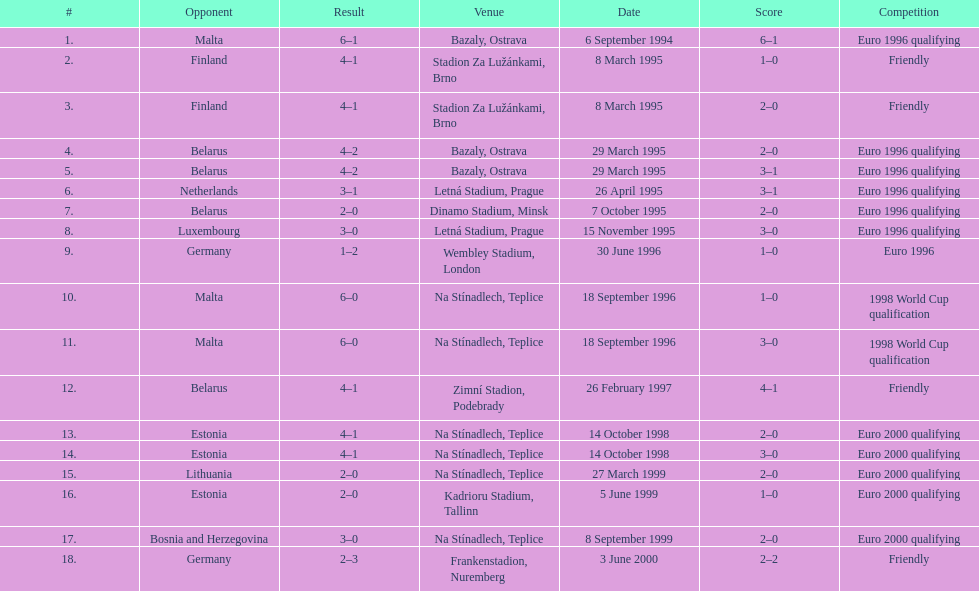List the opponent in which the result was the least out of all the results. Germany. Can you give me this table as a dict? {'header': ['#', 'Opponent', 'Result', 'Venue', 'Date', 'Score', 'Competition'], 'rows': [['1.', 'Malta', '6–1', 'Bazaly, Ostrava', '6 September 1994', '6–1', 'Euro 1996 qualifying'], ['2.', 'Finland', '4–1', 'Stadion Za Lužánkami, Brno', '8 March 1995', '1–0', 'Friendly'], ['3.', 'Finland', '4–1', 'Stadion Za Lužánkami, Brno', '8 March 1995', '2–0', 'Friendly'], ['4.', 'Belarus', '4–2', 'Bazaly, Ostrava', '29 March 1995', '2–0', 'Euro 1996 qualifying'], ['5.', 'Belarus', '4–2', 'Bazaly, Ostrava', '29 March 1995', '3–1', 'Euro 1996 qualifying'], ['6.', 'Netherlands', '3–1', 'Letná Stadium, Prague', '26 April 1995', '3–1', 'Euro 1996 qualifying'], ['7.', 'Belarus', '2–0', 'Dinamo Stadium, Minsk', '7 October 1995', '2–0', 'Euro 1996 qualifying'], ['8.', 'Luxembourg', '3–0', 'Letná Stadium, Prague', '15 November 1995', '3–0', 'Euro 1996 qualifying'], ['9.', 'Germany', '1–2', 'Wembley Stadium, London', '30 June 1996', '1–0', 'Euro 1996'], ['10.', 'Malta', '6–0', 'Na Stínadlech, Teplice', '18 September 1996', '1–0', '1998 World Cup qualification'], ['11.', 'Malta', '6–0', 'Na Stínadlech, Teplice', '18 September 1996', '3–0', '1998 World Cup qualification'], ['12.', 'Belarus', '4–1', 'Zimní Stadion, Podebrady', '26 February 1997', '4–1', 'Friendly'], ['13.', 'Estonia', '4–1', 'Na Stínadlech, Teplice', '14 October 1998', '2–0', 'Euro 2000 qualifying'], ['14.', 'Estonia', '4–1', 'Na Stínadlech, Teplice', '14 October 1998', '3–0', 'Euro 2000 qualifying'], ['15.', 'Lithuania', '2–0', 'Na Stínadlech, Teplice', '27 March 1999', '2–0', 'Euro 2000 qualifying'], ['16.', 'Estonia', '2–0', 'Kadrioru Stadium, Tallinn', '5 June 1999', '1–0', 'Euro 2000 qualifying'], ['17.', 'Bosnia and Herzegovina', '3–0', 'Na Stínadlech, Teplice', '8 September 1999', '2–0', 'Euro 2000 qualifying'], ['18.', 'Germany', '2–3', 'Frankenstadion, Nuremberg', '3 June 2000', '2–2', 'Friendly']]} 